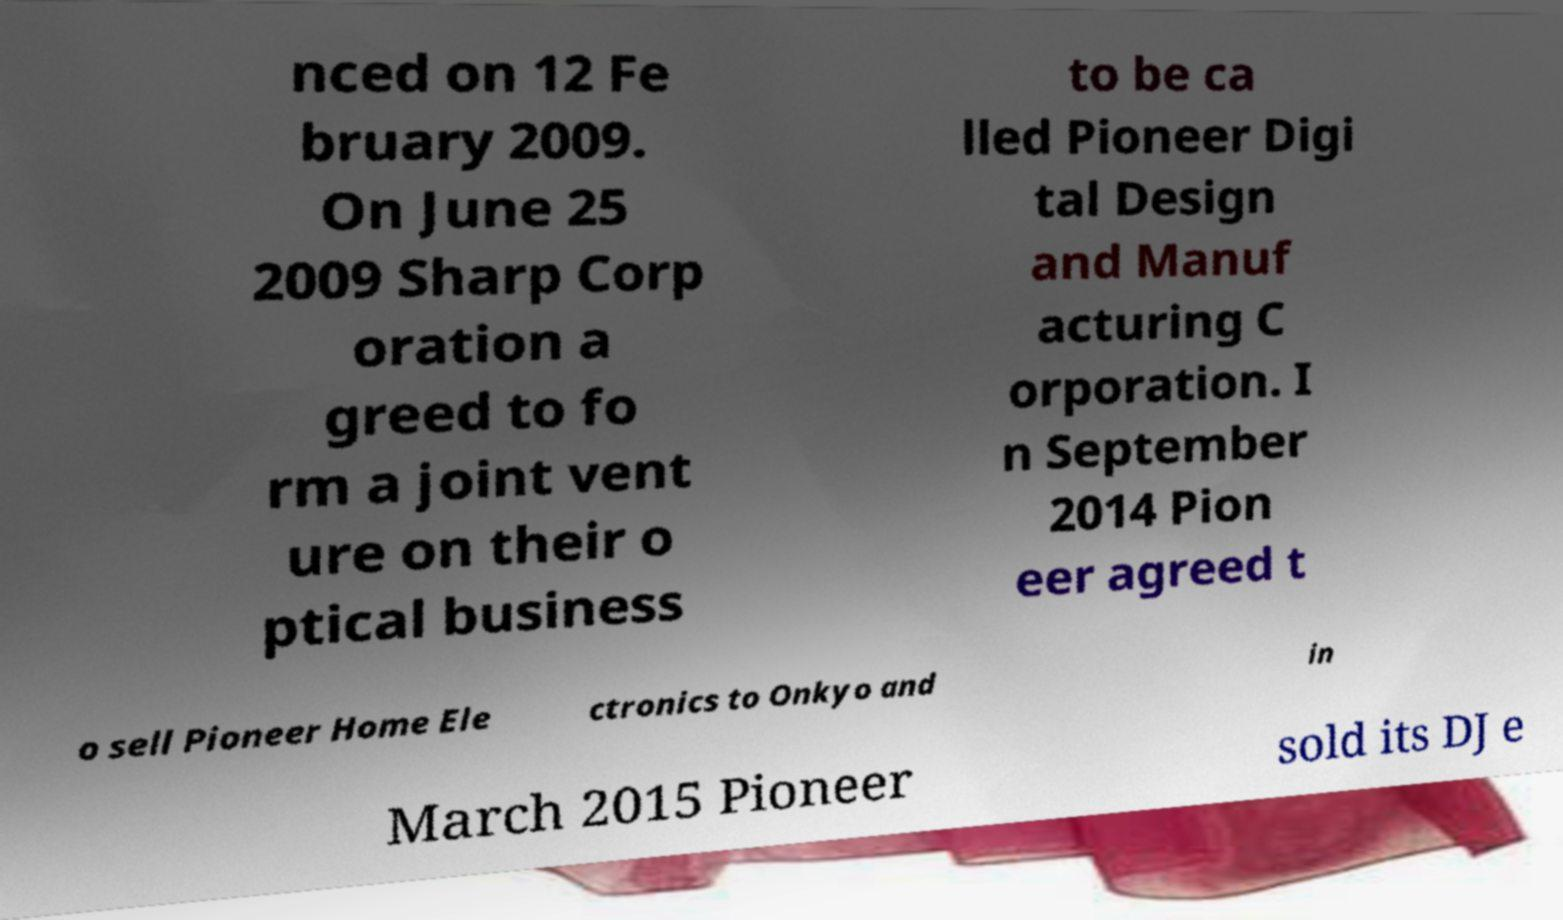Please read and relay the text visible in this image. What does it say? nced on 12 Fe bruary 2009. On June 25 2009 Sharp Corp oration a greed to fo rm a joint vent ure on their o ptical business to be ca lled Pioneer Digi tal Design and Manuf acturing C orporation. I n September 2014 Pion eer agreed t o sell Pioneer Home Ele ctronics to Onkyo and in March 2015 Pioneer sold its DJ e 